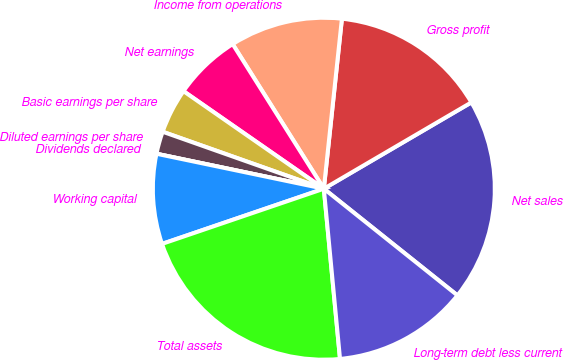Convert chart to OTSL. <chart><loc_0><loc_0><loc_500><loc_500><pie_chart><fcel>Net sales<fcel>Gross profit<fcel>Income from operations<fcel>Net earnings<fcel>Basic earnings per share<fcel>Diluted earnings per share<fcel>Dividends declared<fcel>Working capital<fcel>Total assets<fcel>Long-term debt less current<nl><fcel>19.15%<fcel>14.89%<fcel>10.64%<fcel>6.38%<fcel>4.26%<fcel>2.13%<fcel>0.0%<fcel>8.51%<fcel>21.28%<fcel>12.77%<nl></chart> 